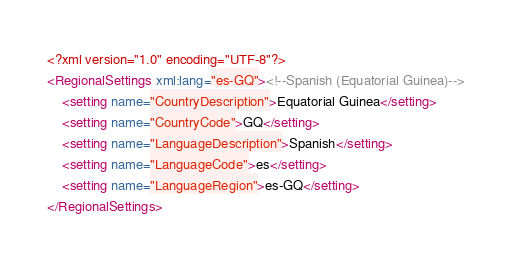Convert code to text. <code><loc_0><loc_0><loc_500><loc_500><_XML_><?xml version="1.0" encoding="UTF-8"?>
<RegionalSettings xml:lang="es-GQ"><!--Spanish (Equatorial Guinea)-->
	<setting name="CountryDescription">Equatorial Guinea</setting>
	<setting name="CountryCode">GQ</setting>
	<setting name="LanguageDescription">Spanish</setting>
	<setting name="LanguageCode">es</setting>
	<setting name="LanguageRegion">es-GQ</setting>
</RegionalSettings>
</code> 